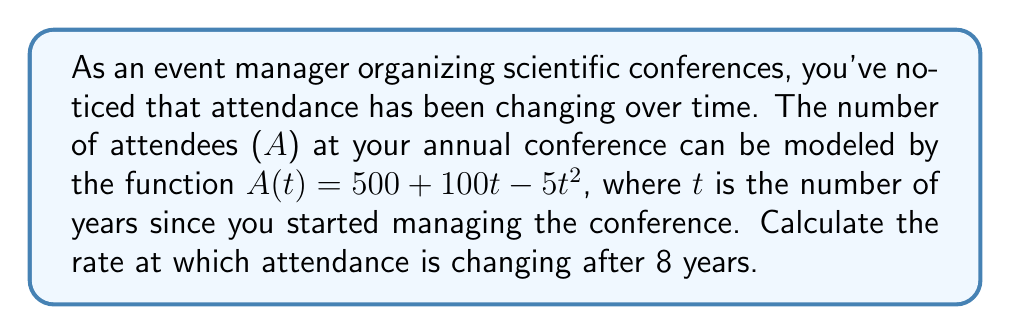Could you help me with this problem? To find the rate of change in conference attendance after 8 years, we need to calculate the derivative of the attendance function $A(t)$ and then evaluate it at $t = 8$.

1. Given attendance function: $A(t) = 500 + 100t - 5t^2$

2. Calculate the derivative $A'(t)$:
   $$\frac{d}{dt}[500 + 100t - 5t^2] = 0 + 100 - 10t$$
   $$A'(t) = 100 - 10t$$

3. Evaluate $A'(t)$ at $t = 8$:
   $$A'(8) = 100 - 10(8) = 100 - 80 = 20$$

The rate of change is positive, indicating that attendance is still increasing after 8 years, but at a slower rate than initially.

To interpret this result in the context of conference management:
- The rate of change is 20 attendees per year at the 8-year mark.
- This suggests that while the conference is still growing, the growth rate is slowing down.
- As an event manager, you might consider strategies to maintain or increase this growth rate in future years.
Answer: The rate of change in conference attendance after 8 years is 20 attendees per year. 